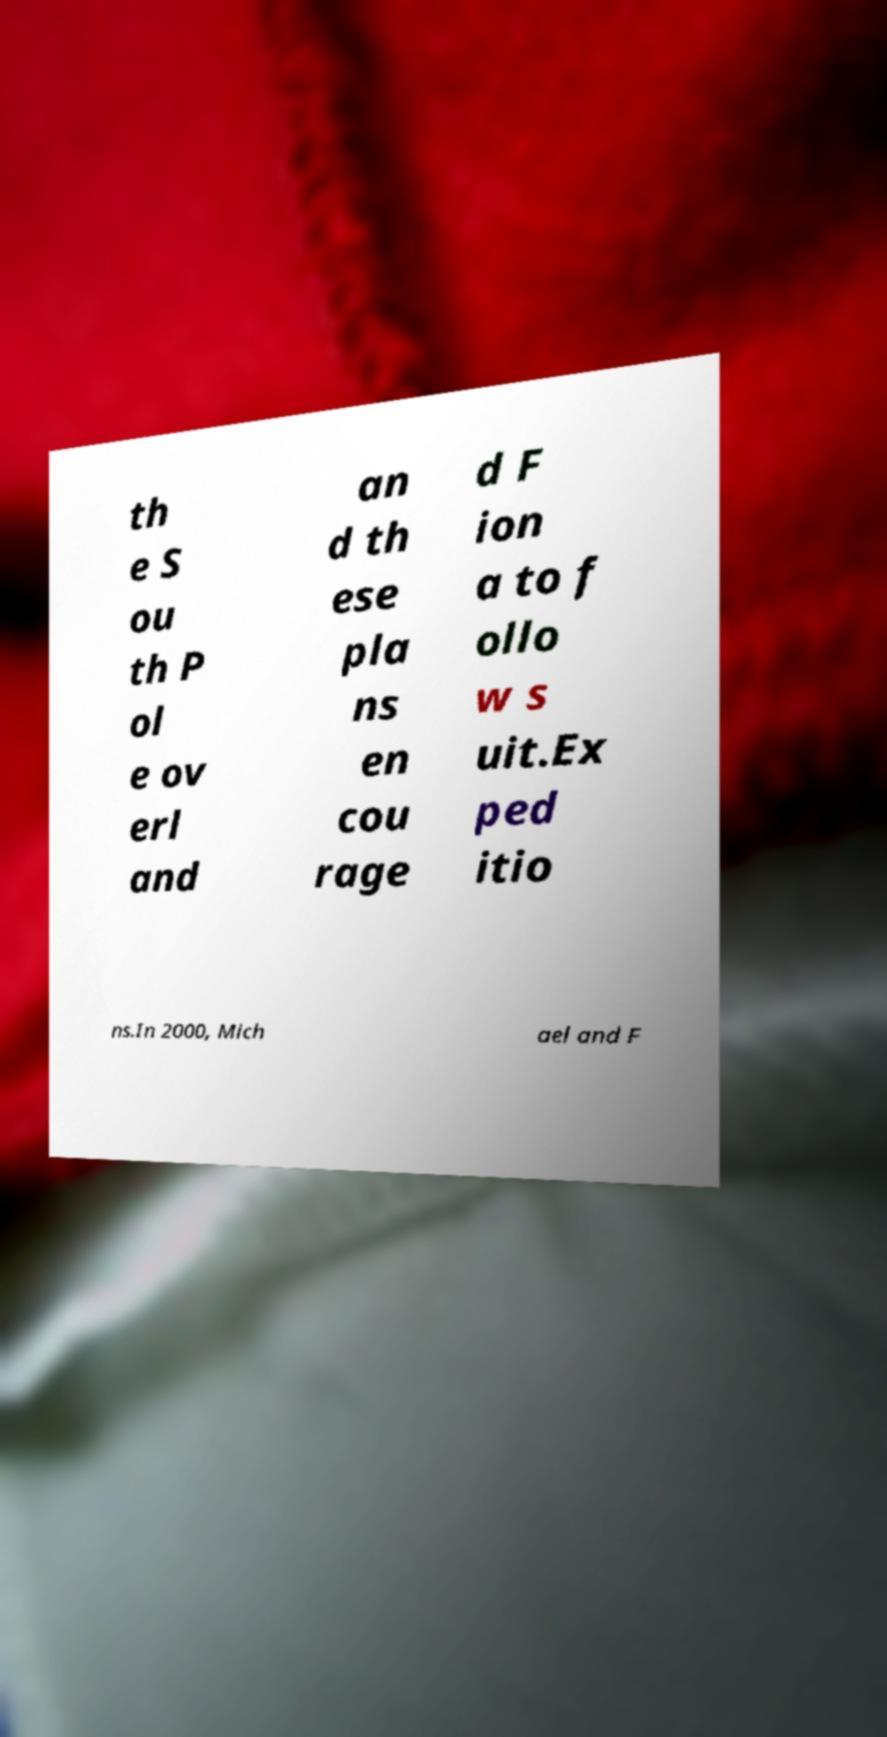What messages or text are displayed in this image? I need them in a readable, typed format. th e S ou th P ol e ov erl and an d th ese pla ns en cou rage d F ion a to f ollo w s uit.Ex ped itio ns.In 2000, Mich ael and F 